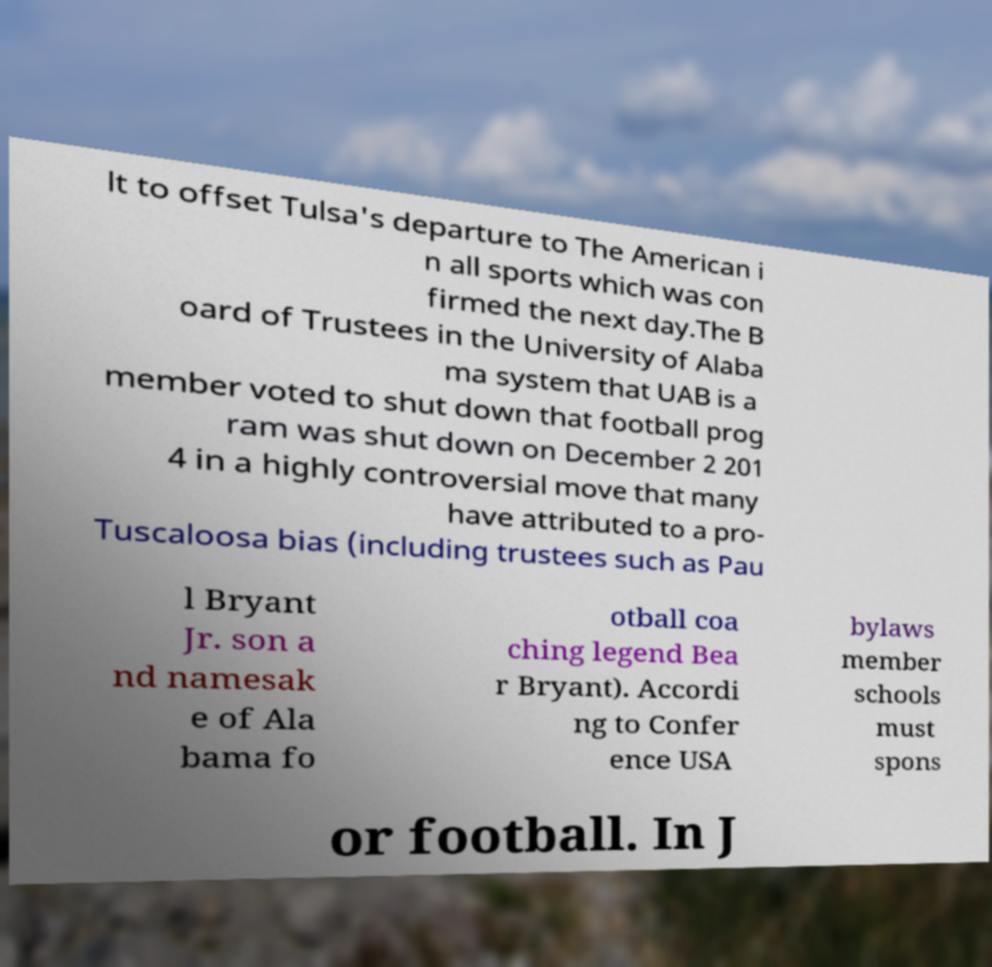Can you read and provide the text displayed in the image?This photo seems to have some interesting text. Can you extract and type it out for me? lt to offset Tulsa's departure to The American i n all sports which was con firmed the next day.The B oard of Trustees in the University of Alaba ma system that UAB is a member voted to shut down that football prog ram was shut down on December 2 201 4 in a highly controversial move that many have attributed to a pro- Tuscaloosa bias (including trustees such as Pau l Bryant Jr. son a nd namesak e of Ala bama fo otball coa ching legend Bea r Bryant). Accordi ng to Confer ence USA bylaws member schools must spons or football. In J 